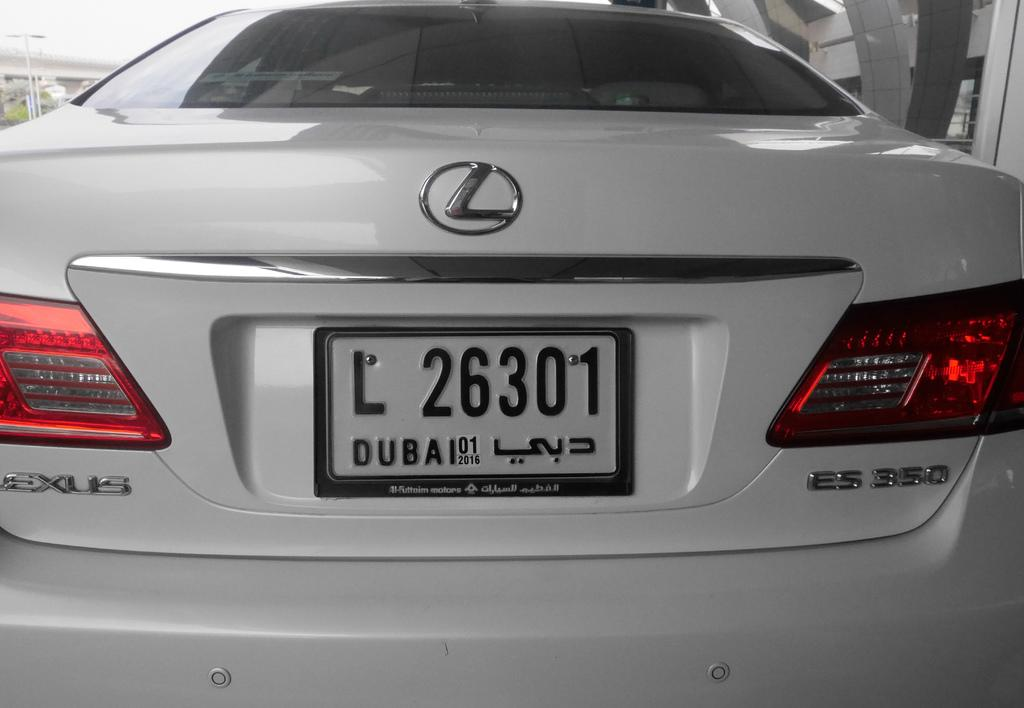<image>
Present a compact description of the photo's key features. White license plate which has the number 26301 on it. 